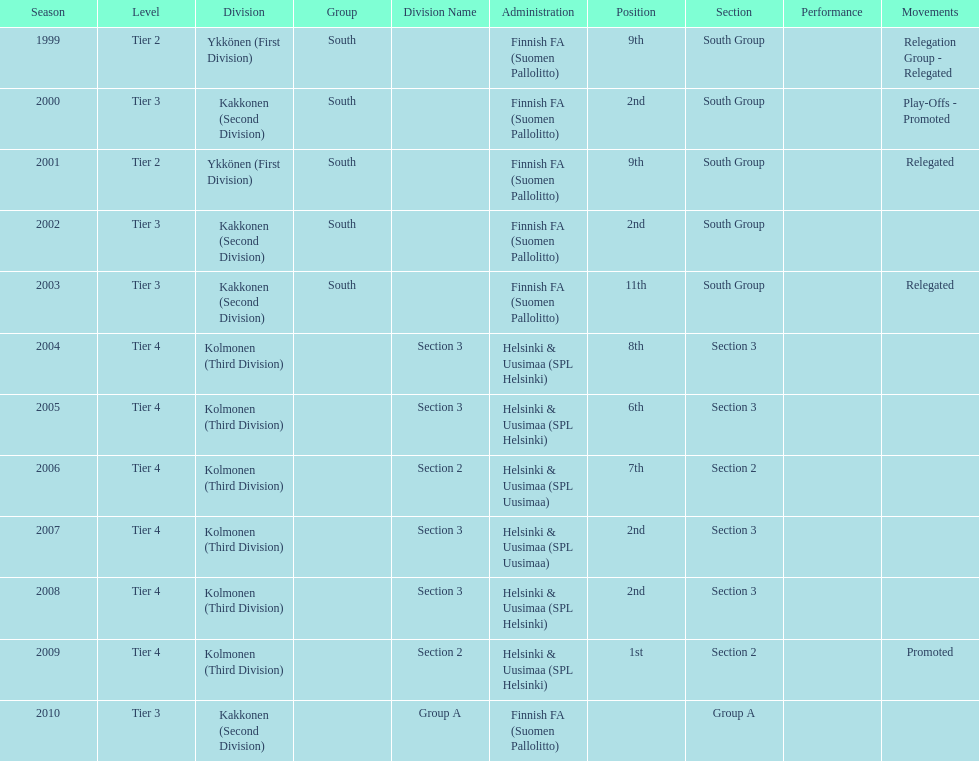How many tiers had more than one relegated movement? 1. Would you mind parsing the complete table? {'header': ['Season', 'Level', 'Division', 'Group', 'Division Name', 'Administration', 'Position', 'Section', 'Performance', 'Movements'], 'rows': [['1999', 'Tier 2', 'Ykkönen (First Division)', 'South', '', 'Finnish FA (Suomen Pallolitto)', '9th', 'South Group', '', 'Relegation Group - Relegated'], ['2000', 'Tier 3', 'Kakkonen (Second Division)', 'South', '', 'Finnish FA (Suomen Pallolitto)', '2nd', 'South Group', '', 'Play-Offs - Promoted'], ['2001', 'Tier 2', 'Ykkönen (First Division)', 'South', '', 'Finnish FA (Suomen Pallolitto)', '9th', 'South Group', '', 'Relegated'], ['2002', 'Tier 3', 'Kakkonen (Second Division)', 'South', '', 'Finnish FA (Suomen Pallolitto)', '2nd', 'South Group', '', ''], ['2003', 'Tier 3', 'Kakkonen (Second Division)', 'South', '', 'Finnish FA (Suomen Pallolitto)', '11th', 'South Group', '', 'Relegated'], ['2004', 'Tier 4', 'Kolmonen (Third Division)', '', 'Section 3', 'Helsinki & Uusimaa (SPL Helsinki)', '8th', 'Section 3', '', ''], ['2005', 'Tier 4', 'Kolmonen (Third Division)', '', 'Section 3', 'Helsinki & Uusimaa (SPL Helsinki)', '6th', 'Section 3', '', ''], ['2006', 'Tier 4', 'Kolmonen (Third Division)', '', 'Section 2', 'Helsinki & Uusimaa (SPL Uusimaa)', '7th', 'Section 2', '', ''], ['2007', 'Tier 4', 'Kolmonen (Third Division)', '', 'Section 3', 'Helsinki & Uusimaa (SPL Uusimaa)', '2nd', 'Section 3', '', ''], ['2008', 'Tier 4', 'Kolmonen (Third Division)', '', 'Section 3', 'Helsinki & Uusimaa (SPL Helsinki)', '2nd', 'Section 3', '', ''], ['2009', 'Tier 4', 'Kolmonen (Third Division)', '', 'Section 2', 'Helsinki & Uusimaa (SPL Helsinki)', '1st', 'Section 2', '', 'Promoted'], ['2010', 'Tier 3', 'Kakkonen (Second Division)', '', 'Group A', 'Finnish FA (Suomen Pallolitto)', '', 'Group A', '', '']]} 